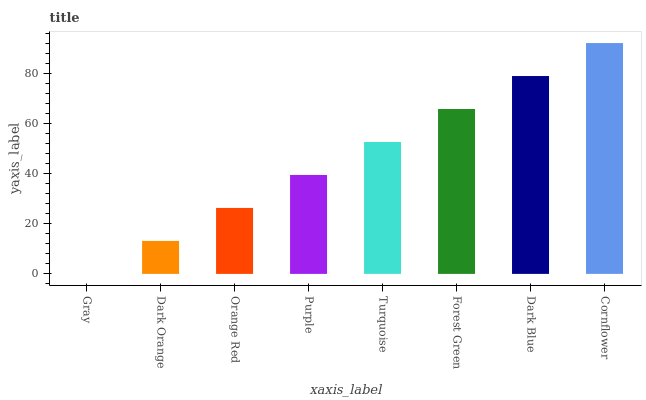Is Gray the minimum?
Answer yes or no. Yes. Is Cornflower the maximum?
Answer yes or no. Yes. Is Dark Orange the minimum?
Answer yes or no. No. Is Dark Orange the maximum?
Answer yes or no. No. Is Dark Orange greater than Gray?
Answer yes or no. Yes. Is Gray less than Dark Orange?
Answer yes or no. Yes. Is Gray greater than Dark Orange?
Answer yes or no. No. Is Dark Orange less than Gray?
Answer yes or no. No. Is Turquoise the high median?
Answer yes or no. Yes. Is Purple the low median?
Answer yes or no. Yes. Is Purple the high median?
Answer yes or no. No. Is Dark Orange the low median?
Answer yes or no. No. 